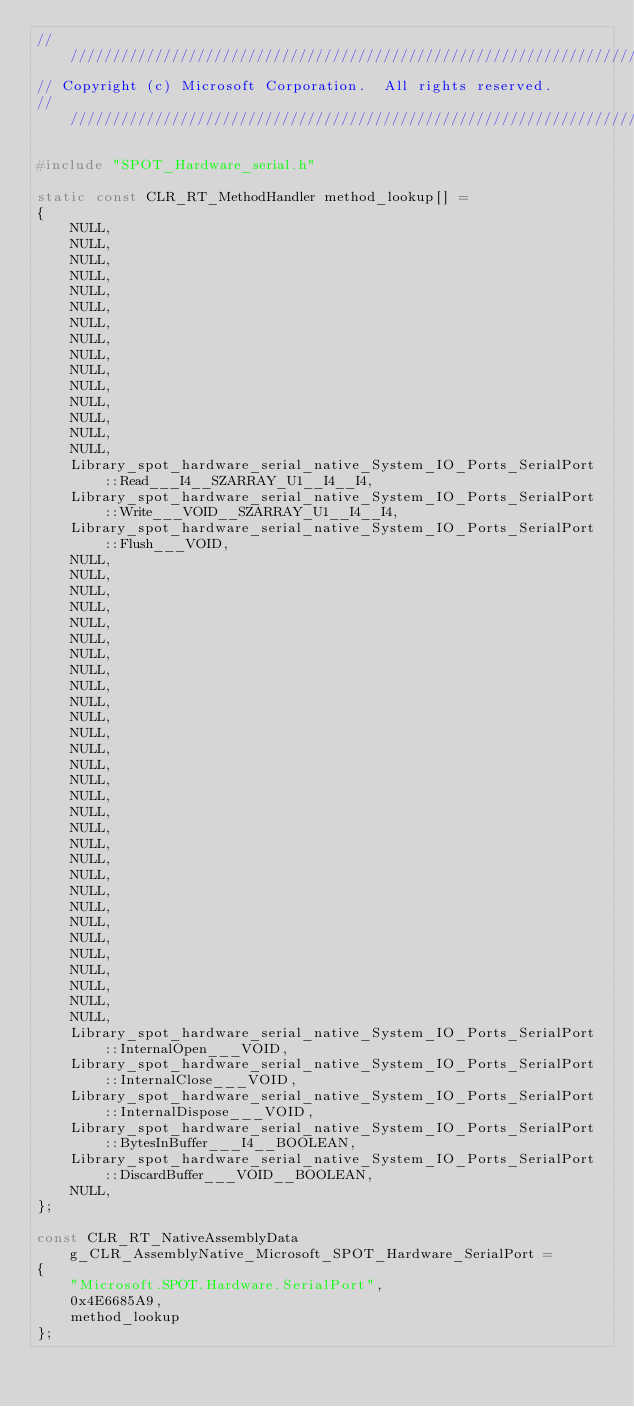<code> <loc_0><loc_0><loc_500><loc_500><_C++_>////////////////////////////////////////////////////////////////////////////////////////////////////////////////////////////////////////////////////////////////////////////////////////////////////////
// Copyright (c) Microsoft Corporation.  All rights reserved.
////////////////////////////////////////////////////////////////////////////////////////////////////////////////////////////////////////////////////////////////////////////////////////////////////////

#include "SPOT_Hardware_serial.h"

static const CLR_RT_MethodHandler method_lookup[] =
{
    NULL,
    NULL,
    NULL,
    NULL,
    NULL,
    NULL,
    NULL,
    NULL,
    NULL,
    NULL,
    NULL,
    NULL,
    NULL,
    NULL,
    NULL,
    Library_spot_hardware_serial_native_System_IO_Ports_SerialPort::Read___I4__SZARRAY_U1__I4__I4,
    Library_spot_hardware_serial_native_System_IO_Ports_SerialPort::Write___VOID__SZARRAY_U1__I4__I4,
    Library_spot_hardware_serial_native_System_IO_Ports_SerialPort::Flush___VOID,
    NULL,
    NULL,
    NULL,
    NULL,
    NULL,
    NULL,
    NULL,
    NULL,
    NULL,
    NULL,
    NULL,
    NULL,
    NULL,
    NULL,
    NULL,
    NULL,
    NULL,
    NULL,
    NULL,
    NULL,
    NULL,
    NULL,
    NULL,
    NULL,
    NULL,
    NULL,
    NULL,
    NULL,
    NULL,
    NULL,
    Library_spot_hardware_serial_native_System_IO_Ports_SerialPort::InternalOpen___VOID,
    Library_spot_hardware_serial_native_System_IO_Ports_SerialPort::InternalClose___VOID,
    Library_spot_hardware_serial_native_System_IO_Ports_SerialPort::InternalDispose___VOID,
    Library_spot_hardware_serial_native_System_IO_Ports_SerialPort::BytesInBuffer___I4__BOOLEAN,
    Library_spot_hardware_serial_native_System_IO_Ports_SerialPort::DiscardBuffer___VOID__BOOLEAN,
    NULL,
};

const CLR_RT_NativeAssemblyData g_CLR_AssemblyNative_Microsoft_SPOT_Hardware_SerialPort =
{
    "Microsoft.SPOT.Hardware.SerialPort", 
    0x4E6685A9,
    method_lookup
};

</code> 